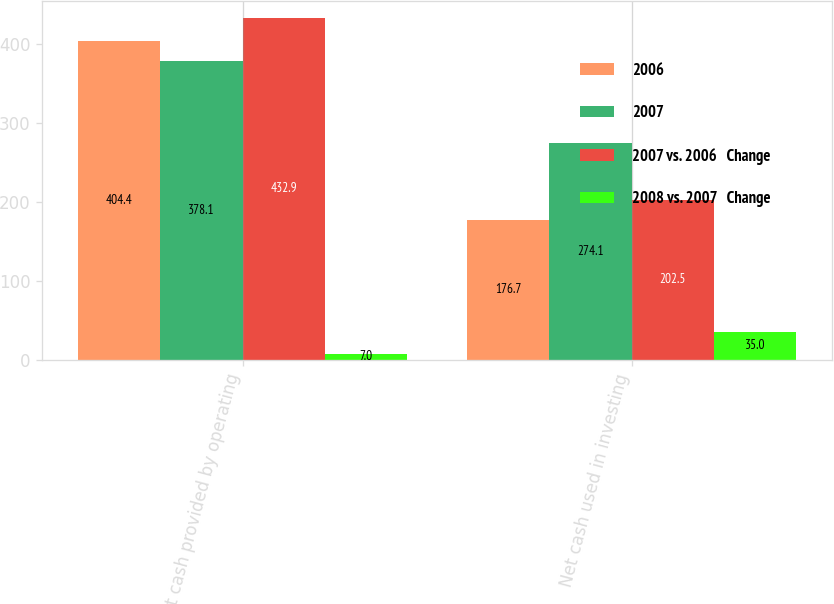<chart> <loc_0><loc_0><loc_500><loc_500><stacked_bar_chart><ecel><fcel>Net cash provided by operating<fcel>Net cash used in investing<nl><fcel>2006<fcel>404.4<fcel>176.7<nl><fcel>2007<fcel>378.1<fcel>274.1<nl><fcel>2007 vs. 2006   Change<fcel>432.9<fcel>202.5<nl><fcel>2008 vs. 2007   Change<fcel>7<fcel>35<nl></chart> 